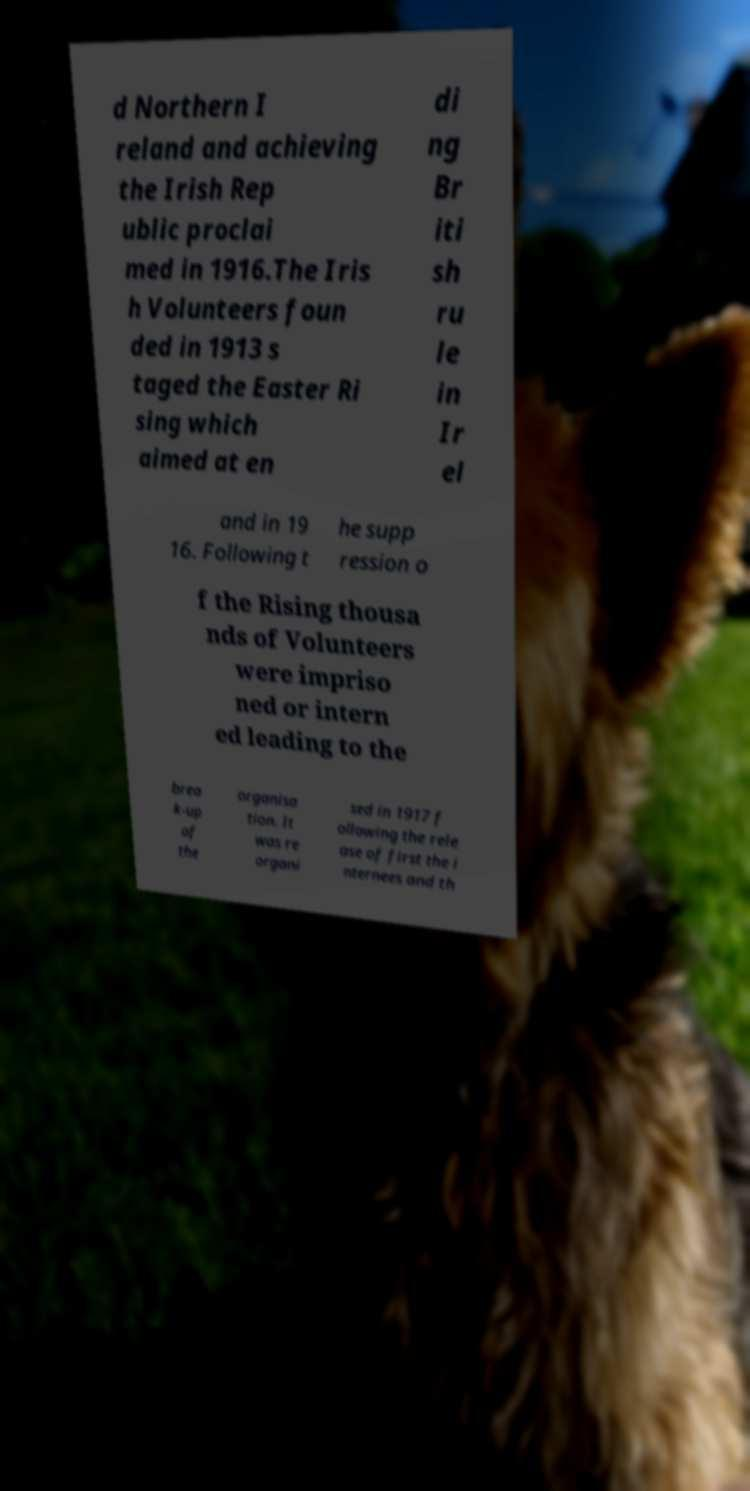I need the written content from this picture converted into text. Can you do that? d Northern I reland and achieving the Irish Rep ublic proclai med in 1916.The Iris h Volunteers foun ded in 1913 s taged the Easter Ri sing which aimed at en di ng Br iti sh ru le in Ir el and in 19 16. Following t he supp ression o f the Rising thousa nds of Volunteers were impriso ned or intern ed leading to the brea k-up of the organisa tion. It was re organi sed in 1917 f ollowing the rele ase of first the i nternees and th 